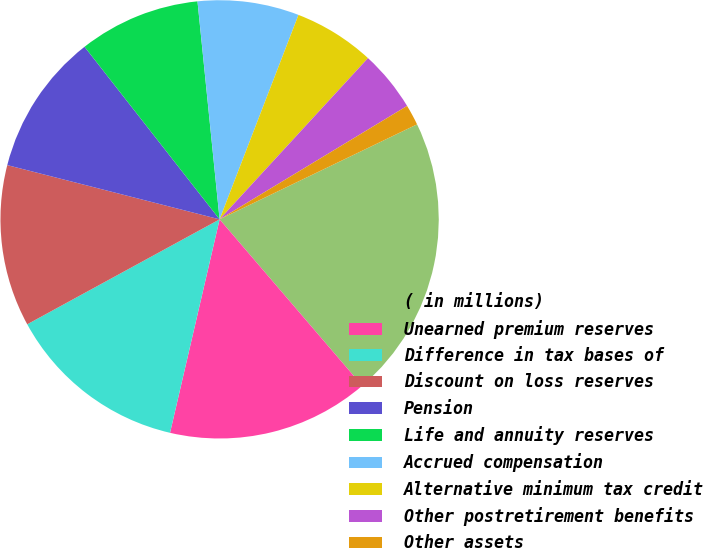Convert chart. <chart><loc_0><loc_0><loc_500><loc_500><pie_chart><fcel>( in millions)<fcel>Unearned premium reserves<fcel>Difference in tax bases of<fcel>Discount on loss reserves<fcel>Pension<fcel>Life and annuity reserves<fcel>Accrued compensation<fcel>Alternative minimum tax credit<fcel>Other postretirement benefits<fcel>Other assets<nl><fcel>20.86%<fcel>14.91%<fcel>13.42%<fcel>11.93%<fcel>10.45%<fcel>8.96%<fcel>7.47%<fcel>5.98%<fcel>4.5%<fcel>1.52%<nl></chart> 